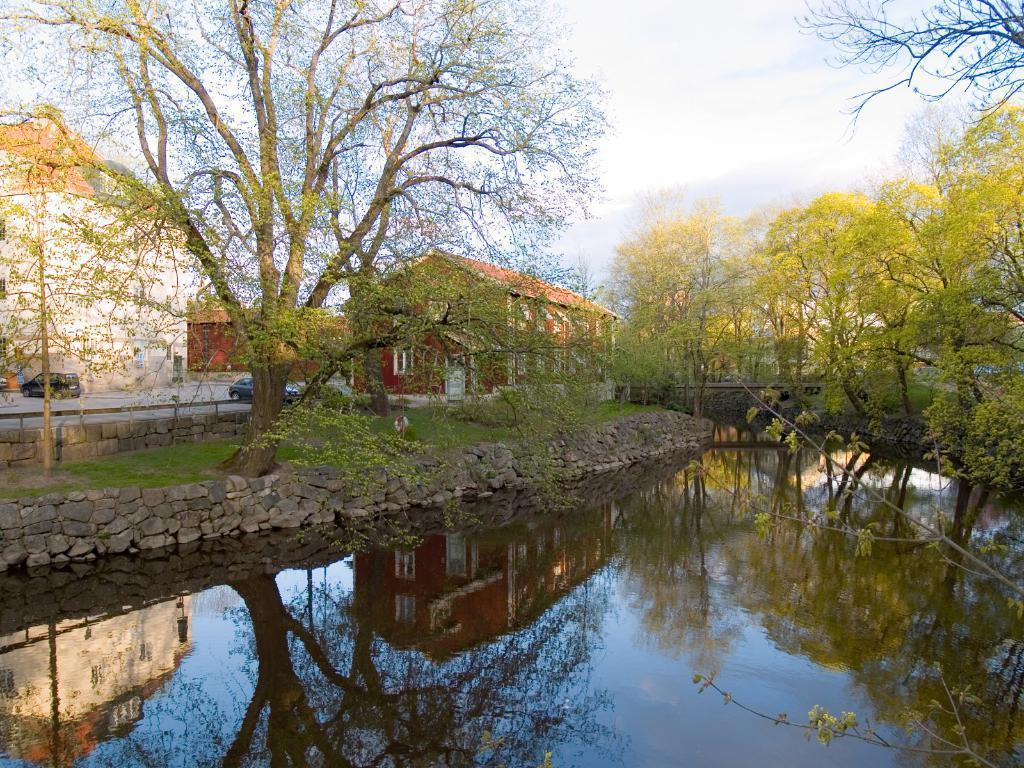Describe this image in one or two sentences. At the bottom of the image there is water. Behind the water to the left side there are few stones. Behind the stones there is a ground with grass and trees. In the background there are few houses with walls and roofs. And also there are cars on the road. And to the top of the image there is a sky in the background. 